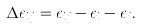<formula> <loc_0><loc_0><loc_500><loc_500>\Delta \epsilon _ { i j } = \epsilon _ { i j } - \epsilon _ { i } - \epsilon _ { j } .</formula> 